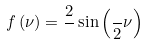Convert formula to latex. <formula><loc_0><loc_0><loc_500><loc_500>f \left ( \nu \right ) = \frac { 2 } { } \sin \left ( \frac { } { 2 } \nu \right )</formula> 